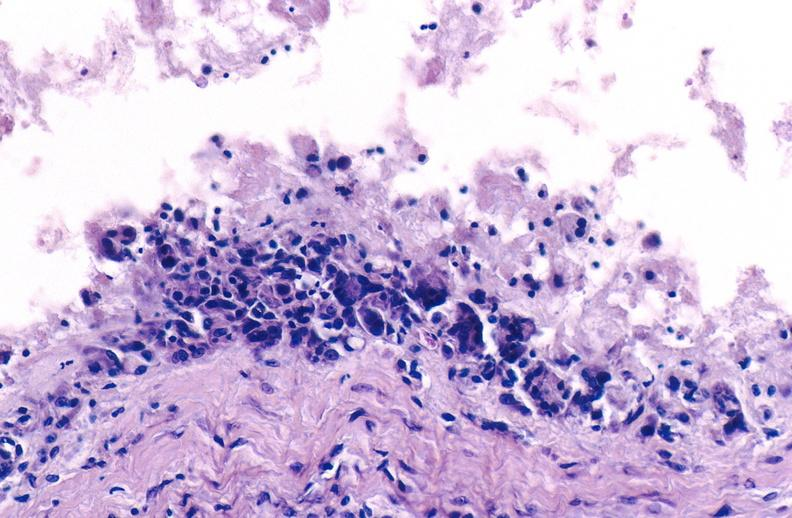does vasculitis foreign body show gout?
Answer the question using a single word or phrase. No 